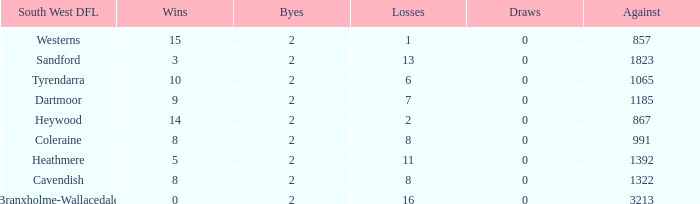How many wins have 16 losses and an Against smaller than 3213? None. 